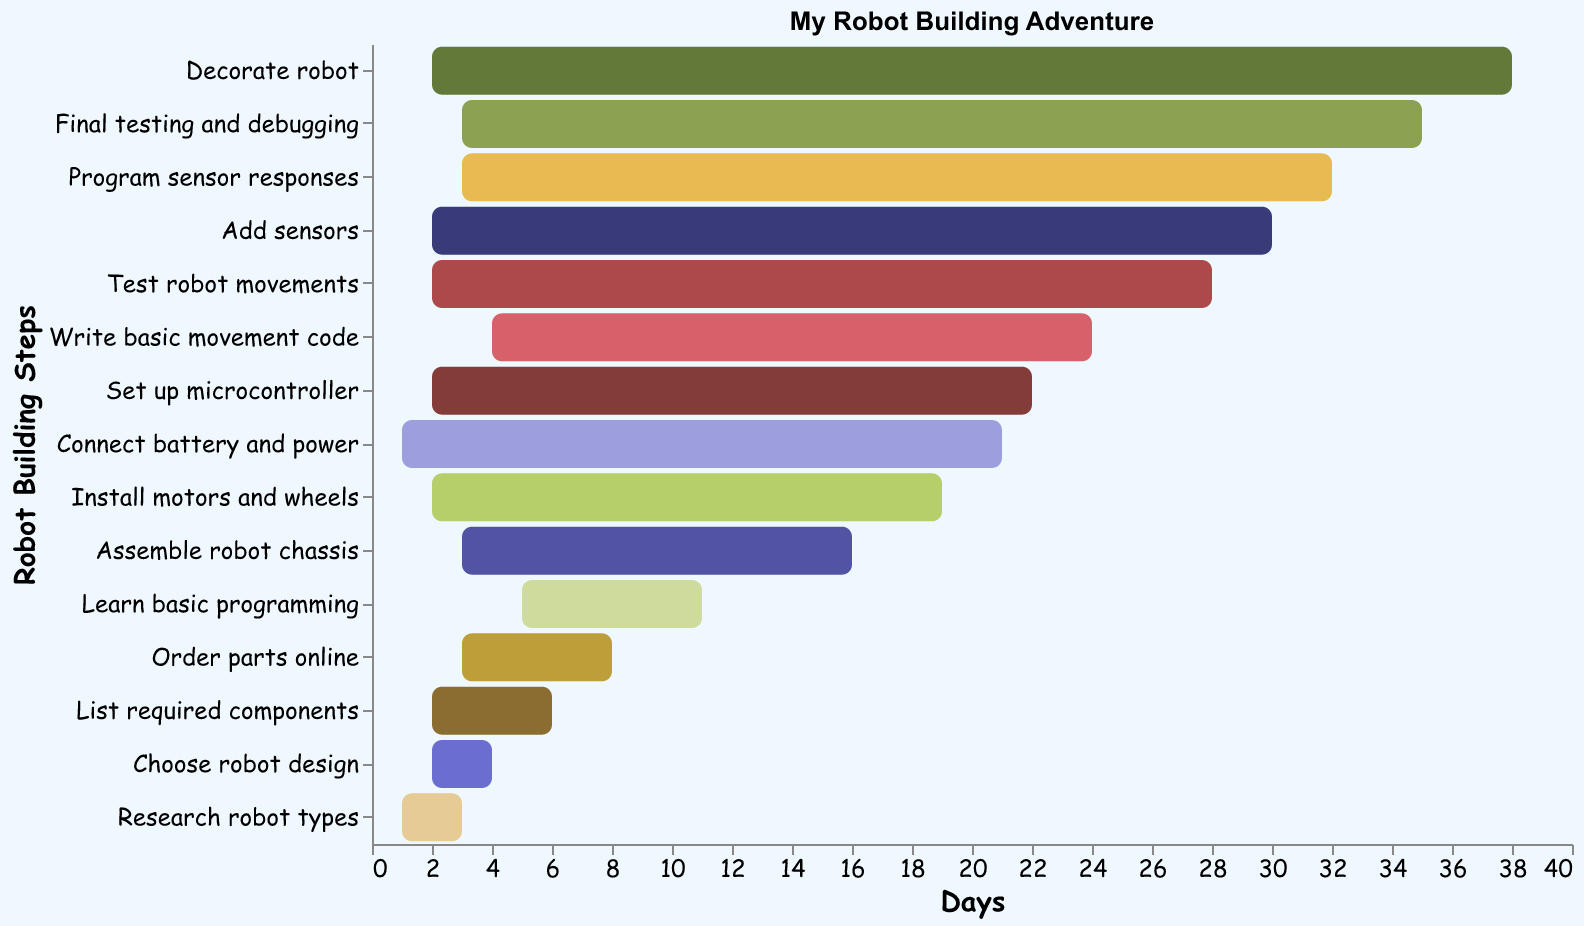Which task starts on Day 11? The figure shows a bar starting on Day 11 labeled "Learn basic programming."
Answer: Learn basic programming How long does it take to assemble the robot chassis? The bar for "Assemble robot chassis" spans 3 days, indicating the duration.
Answer: 3 days What is the first task in building the robot? The first bar at the bottom is labeled "Research robot types," which starts on Day 1.
Answer: Research robot types Which task takes the longest? The longest bar in the figure represents "Learn basic programming," which spans 5 days.
Answer: Learn basic programming What days are used to program the sensor responses? The bar for "Program sensor responses" starts on Day 32 and, with a duration of 3 days, it ends on Day 35.
Answer: Days 32 to 35 Which task comes immediately after ordering parts online? The "Order parts online" task ends on Day 11, and the next task starting on Day 11 is "Learn basic programming."
Answer: Learn basic programming If you start writing the basic movement code on Day 24, when will it finish? The task "Write basic movement code" spans 4 days starting on Day 24, so it should finish on Day 28.
Answer: Day 28 Compare the duration of testing robot movements and adding sensors. Which one is shorter? The bar for "Test robot movements" spans 2 days, the same as "Add sensors." Therefore, their durations are equal.
Answer: They are equal What are the overlapping tasks with days between 20 and 25? The tasks include "Install motors and wheels" (Day 19 to 21), "Connect battery and power" (Day 21 to 22), "Set up microcontroller" (Day 22 to 24), and "Write basic movement code" (Day 24 to 28).
Answer: Install motors and wheels, Connect battery and power, Set up microcontroller, Write basic movement code How many tasks have a duration of exactly 2 days? The figure shows "Choose robot design," "List required components," "Install motors and wheels," "Set up microcontroller," "Test robot movements," "Add sensors," each spanning exactly 2 days. Counting them gives a total of 6 tasks.
Answer: 6 tasks 